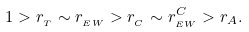<formula> <loc_0><loc_0><loc_500><loc_500>1 > r _ { _ { T } } \sim r _ { _ { E W } } > r _ { _ { C } } \sim r _ { _ { E W } } ^ { C } > r _ { A } .</formula> 